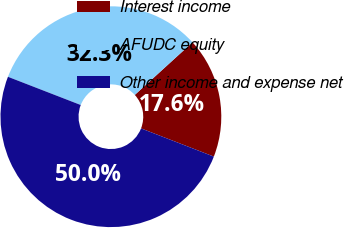<chart> <loc_0><loc_0><loc_500><loc_500><pie_chart><fcel>Interest income<fcel>AFUDC equity<fcel>Other income and expense net<nl><fcel>17.65%<fcel>32.35%<fcel>50.0%<nl></chart> 